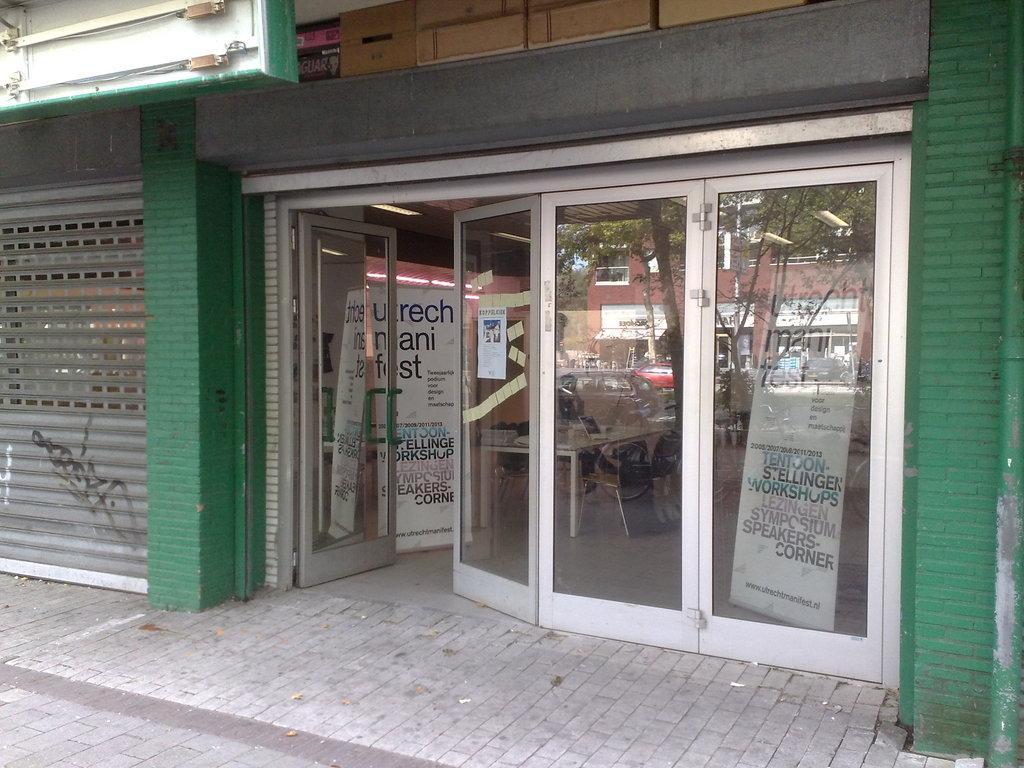Can you describe this image briefly? In this image we can see a building with the glass doors and a shutter. We can also see some banners with text on it, a table containing some objects on it and a chair inside a building. At the top left we can see some lights to a board. On the right side we can see a pipe. 